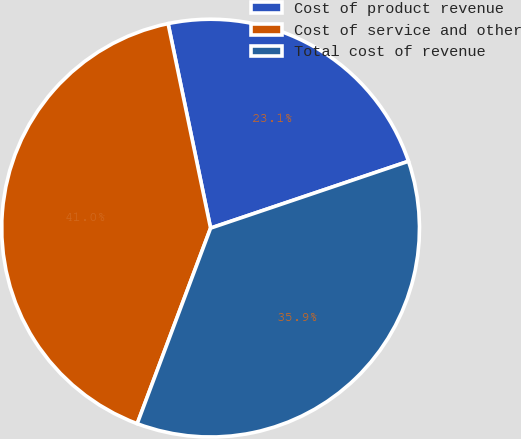Convert chart to OTSL. <chart><loc_0><loc_0><loc_500><loc_500><pie_chart><fcel>Cost of product revenue<fcel>Cost of service and other<fcel>Total cost of revenue<nl><fcel>23.08%<fcel>41.03%<fcel>35.9%<nl></chart> 